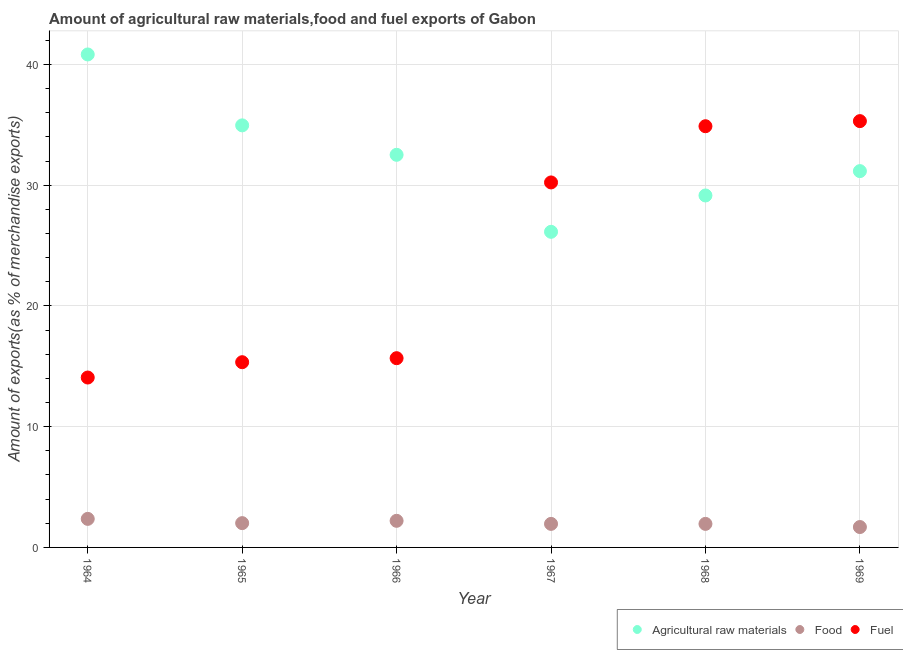How many different coloured dotlines are there?
Ensure brevity in your answer.  3. Is the number of dotlines equal to the number of legend labels?
Offer a terse response. Yes. What is the percentage of raw materials exports in 1968?
Provide a succinct answer. 29.15. Across all years, what is the maximum percentage of raw materials exports?
Offer a terse response. 40.83. Across all years, what is the minimum percentage of raw materials exports?
Provide a short and direct response. 26.14. In which year was the percentage of fuel exports maximum?
Ensure brevity in your answer.  1969. In which year was the percentage of food exports minimum?
Your answer should be very brief. 1969. What is the total percentage of raw materials exports in the graph?
Provide a succinct answer. 194.74. What is the difference between the percentage of food exports in 1968 and that in 1969?
Your response must be concise. 0.26. What is the difference between the percentage of fuel exports in 1968 and the percentage of food exports in 1967?
Provide a short and direct response. 32.93. What is the average percentage of food exports per year?
Ensure brevity in your answer.  2.03. In the year 1965, what is the difference between the percentage of fuel exports and percentage of food exports?
Keep it short and to the point. 13.33. What is the ratio of the percentage of food exports in 1964 to that in 1965?
Make the answer very short. 1.18. What is the difference between the highest and the second highest percentage of food exports?
Offer a very short reply. 0.16. What is the difference between the highest and the lowest percentage of fuel exports?
Provide a succinct answer. 21.23. In how many years, is the percentage of fuel exports greater than the average percentage of fuel exports taken over all years?
Give a very brief answer. 3. Is the sum of the percentage of raw materials exports in 1966 and 1967 greater than the maximum percentage of food exports across all years?
Your response must be concise. Yes. Is the percentage of fuel exports strictly greater than the percentage of food exports over the years?
Offer a terse response. Yes. Is the percentage of raw materials exports strictly less than the percentage of fuel exports over the years?
Your answer should be compact. No. How many dotlines are there?
Give a very brief answer. 3. What is the difference between two consecutive major ticks on the Y-axis?
Give a very brief answer. 10. Are the values on the major ticks of Y-axis written in scientific E-notation?
Provide a short and direct response. No. Does the graph contain any zero values?
Your answer should be compact. No. Does the graph contain grids?
Provide a succinct answer. Yes. How are the legend labels stacked?
Provide a short and direct response. Horizontal. What is the title of the graph?
Provide a succinct answer. Amount of agricultural raw materials,food and fuel exports of Gabon. What is the label or title of the X-axis?
Make the answer very short. Year. What is the label or title of the Y-axis?
Your response must be concise. Amount of exports(as % of merchandise exports). What is the Amount of exports(as % of merchandise exports) in Agricultural raw materials in 1964?
Your response must be concise. 40.83. What is the Amount of exports(as % of merchandise exports) in Food in 1964?
Provide a short and direct response. 2.36. What is the Amount of exports(as % of merchandise exports) of Fuel in 1964?
Offer a very short reply. 14.07. What is the Amount of exports(as % of merchandise exports) of Agricultural raw materials in 1965?
Ensure brevity in your answer.  34.95. What is the Amount of exports(as % of merchandise exports) of Food in 1965?
Keep it short and to the point. 2.01. What is the Amount of exports(as % of merchandise exports) in Fuel in 1965?
Your answer should be compact. 15.34. What is the Amount of exports(as % of merchandise exports) of Agricultural raw materials in 1966?
Give a very brief answer. 32.51. What is the Amount of exports(as % of merchandise exports) of Food in 1966?
Give a very brief answer. 2.2. What is the Amount of exports(as % of merchandise exports) of Fuel in 1966?
Ensure brevity in your answer.  15.67. What is the Amount of exports(as % of merchandise exports) in Agricultural raw materials in 1967?
Provide a short and direct response. 26.14. What is the Amount of exports(as % of merchandise exports) in Food in 1967?
Provide a short and direct response. 1.95. What is the Amount of exports(as % of merchandise exports) of Fuel in 1967?
Keep it short and to the point. 30.23. What is the Amount of exports(as % of merchandise exports) of Agricultural raw materials in 1968?
Your answer should be compact. 29.15. What is the Amount of exports(as % of merchandise exports) of Food in 1968?
Offer a terse response. 1.95. What is the Amount of exports(as % of merchandise exports) of Fuel in 1968?
Ensure brevity in your answer.  34.88. What is the Amount of exports(as % of merchandise exports) in Agricultural raw materials in 1969?
Offer a very short reply. 31.16. What is the Amount of exports(as % of merchandise exports) of Food in 1969?
Give a very brief answer. 1.69. What is the Amount of exports(as % of merchandise exports) in Fuel in 1969?
Your answer should be very brief. 35.3. Across all years, what is the maximum Amount of exports(as % of merchandise exports) in Agricultural raw materials?
Provide a succinct answer. 40.83. Across all years, what is the maximum Amount of exports(as % of merchandise exports) in Food?
Your answer should be compact. 2.36. Across all years, what is the maximum Amount of exports(as % of merchandise exports) of Fuel?
Give a very brief answer. 35.3. Across all years, what is the minimum Amount of exports(as % of merchandise exports) of Agricultural raw materials?
Keep it short and to the point. 26.14. Across all years, what is the minimum Amount of exports(as % of merchandise exports) of Food?
Ensure brevity in your answer.  1.69. Across all years, what is the minimum Amount of exports(as % of merchandise exports) of Fuel?
Your response must be concise. 14.07. What is the total Amount of exports(as % of merchandise exports) of Agricultural raw materials in the graph?
Give a very brief answer. 194.74. What is the total Amount of exports(as % of merchandise exports) in Food in the graph?
Provide a short and direct response. 12.17. What is the total Amount of exports(as % of merchandise exports) in Fuel in the graph?
Your answer should be very brief. 145.5. What is the difference between the Amount of exports(as % of merchandise exports) of Agricultural raw materials in 1964 and that in 1965?
Your answer should be compact. 5.87. What is the difference between the Amount of exports(as % of merchandise exports) of Food in 1964 and that in 1965?
Provide a succinct answer. 0.35. What is the difference between the Amount of exports(as % of merchandise exports) in Fuel in 1964 and that in 1965?
Provide a succinct answer. -1.27. What is the difference between the Amount of exports(as % of merchandise exports) of Agricultural raw materials in 1964 and that in 1966?
Ensure brevity in your answer.  8.31. What is the difference between the Amount of exports(as % of merchandise exports) of Food in 1964 and that in 1966?
Provide a short and direct response. 0.16. What is the difference between the Amount of exports(as % of merchandise exports) in Fuel in 1964 and that in 1966?
Give a very brief answer. -1.6. What is the difference between the Amount of exports(as % of merchandise exports) in Agricultural raw materials in 1964 and that in 1967?
Offer a very short reply. 14.69. What is the difference between the Amount of exports(as % of merchandise exports) of Food in 1964 and that in 1967?
Keep it short and to the point. 0.42. What is the difference between the Amount of exports(as % of merchandise exports) of Fuel in 1964 and that in 1967?
Offer a very short reply. -16.16. What is the difference between the Amount of exports(as % of merchandise exports) in Agricultural raw materials in 1964 and that in 1968?
Provide a short and direct response. 11.68. What is the difference between the Amount of exports(as % of merchandise exports) in Food in 1964 and that in 1968?
Offer a terse response. 0.41. What is the difference between the Amount of exports(as % of merchandise exports) of Fuel in 1964 and that in 1968?
Make the answer very short. -20.81. What is the difference between the Amount of exports(as % of merchandise exports) in Agricultural raw materials in 1964 and that in 1969?
Give a very brief answer. 9.66. What is the difference between the Amount of exports(as % of merchandise exports) of Food in 1964 and that in 1969?
Provide a succinct answer. 0.68. What is the difference between the Amount of exports(as % of merchandise exports) of Fuel in 1964 and that in 1969?
Make the answer very short. -21.23. What is the difference between the Amount of exports(as % of merchandise exports) of Agricultural raw materials in 1965 and that in 1966?
Make the answer very short. 2.44. What is the difference between the Amount of exports(as % of merchandise exports) in Food in 1965 and that in 1966?
Make the answer very short. -0.19. What is the difference between the Amount of exports(as % of merchandise exports) in Fuel in 1965 and that in 1966?
Offer a terse response. -0.33. What is the difference between the Amount of exports(as % of merchandise exports) of Agricultural raw materials in 1965 and that in 1967?
Ensure brevity in your answer.  8.82. What is the difference between the Amount of exports(as % of merchandise exports) in Food in 1965 and that in 1967?
Your answer should be compact. 0.06. What is the difference between the Amount of exports(as % of merchandise exports) in Fuel in 1965 and that in 1967?
Keep it short and to the point. -14.89. What is the difference between the Amount of exports(as % of merchandise exports) of Agricultural raw materials in 1965 and that in 1968?
Provide a short and direct response. 5.81. What is the difference between the Amount of exports(as % of merchandise exports) of Food in 1965 and that in 1968?
Your answer should be compact. 0.06. What is the difference between the Amount of exports(as % of merchandise exports) of Fuel in 1965 and that in 1968?
Your response must be concise. -19.54. What is the difference between the Amount of exports(as % of merchandise exports) in Agricultural raw materials in 1965 and that in 1969?
Your answer should be very brief. 3.79. What is the difference between the Amount of exports(as % of merchandise exports) in Food in 1965 and that in 1969?
Your response must be concise. 0.32. What is the difference between the Amount of exports(as % of merchandise exports) in Fuel in 1965 and that in 1969?
Give a very brief answer. -19.97. What is the difference between the Amount of exports(as % of merchandise exports) in Agricultural raw materials in 1966 and that in 1967?
Your response must be concise. 6.38. What is the difference between the Amount of exports(as % of merchandise exports) in Food in 1966 and that in 1967?
Your response must be concise. 0.25. What is the difference between the Amount of exports(as % of merchandise exports) in Fuel in 1966 and that in 1967?
Your response must be concise. -14.55. What is the difference between the Amount of exports(as % of merchandise exports) in Agricultural raw materials in 1966 and that in 1968?
Give a very brief answer. 3.37. What is the difference between the Amount of exports(as % of merchandise exports) of Food in 1966 and that in 1968?
Your answer should be very brief. 0.25. What is the difference between the Amount of exports(as % of merchandise exports) of Fuel in 1966 and that in 1968?
Ensure brevity in your answer.  -19.21. What is the difference between the Amount of exports(as % of merchandise exports) of Agricultural raw materials in 1966 and that in 1969?
Your answer should be very brief. 1.35. What is the difference between the Amount of exports(as % of merchandise exports) in Food in 1966 and that in 1969?
Keep it short and to the point. 0.51. What is the difference between the Amount of exports(as % of merchandise exports) of Fuel in 1966 and that in 1969?
Offer a terse response. -19.63. What is the difference between the Amount of exports(as % of merchandise exports) in Agricultural raw materials in 1967 and that in 1968?
Ensure brevity in your answer.  -3.01. What is the difference between the Amount of exports(as % of merchandise exports) in Food in 1967 and that in 1968?
Your response must be concise. -0. What is the difference between the Amount of exports(as % of merchandise exports) in Fuel in 1967 and that in 1968?
Your answer should be compact. -4.66. What is the difference between the Amount of exports(as % of merchandise exports) of Agricultural raw materials in 1967 and that in 1969?
Offer a terse response. -5.03. What is the difference between the Amount of exports(as % of merchandise exports) of Food in 1967 and that in 1969?
Your answer should be very brief. 0.26. What is the difference between the Amount of exports(as % of merchandise exports) of Fuel in 1967 and that in 1969?
Your answer should be very brief. -5.08. What is the difference between the Amount of exports(as % of merchandise exports) of Agricultural raw materials in 1968 and that in 1969?
Offer a very short reply. -2.02. What is the difference between the Amount of exports(as % of merchandise exports) of Food in 1968 and that in 1969?
Your response must be concise. 0.26. What is the difference between the Amount of exports(as % of merchandise exports) of Fuel in 1968 and that in 1969?
Your answer should be compact. -0.42. What is the difference between the Amount of exports(as % of merchandise exports) of Agricultural raw materials in 1964 and the Amount of exports(as % of merchandise exports) of Food in 1965?
Keep it short and to the point. 38.81. What is the difference between the Amount of exports(as % of merchandise exports) in Agricultural raw materials in 1964 and the Amount of exports(as % of merchandise exports) in Fuel in 1965?
Make the answer very short. 25.49. What is the difference between the Amount of exports(as % of merchandise exports) of Food in 1964 and the Amount of exports(as % of merchandise exports) of Fuel in 1965?
Offer a terse response. -12.97. What is the difference between the Amount of exports(as % of merchandise exports) in Agricultural raw materials in 1964 and the Amount of exports(as % of merchandise exports) in Food in 1966?
Your response must be concise. 38.62. What is the difference between the Amount of exports(as % of merchandise exports) of Agricultural raw materials in 1964 and the Amount of exports(as % of merchandise exports) of Fuel in 1966?
Keep it short and to the point. 25.15. What is the difference between the Amount of exports(as % of merchandise exports) in Food in 1964 and the Amount of exports(as % of merchandise exports) in Fuel in 1966?
Your answer should be very brief. -13.31. What is the difference between the Amount of exports(as % of merchandise exports) in Agricultural raw materials in 1964 and the Amount of exports(as % of merchandise exports) in Food in 1967?
Your answer should be compact. 38.88. What is the difference between the Amount of exports(as % of merchandise exports) of Agricultural raw materials in 1964 and the Amount of exports(as % of merchandise exports) of Fuel in 1967?
Your response must be concise. 10.6. What is the difference between the Amount of exports(as % of merchandise exports) of Food in 1964 and the Amount of exports(as % of merchandise exports) of Fuel in 1967?
Give a very brief answer. -27.86. What is the difference between the Amount of exports(as % of merchandise exports) of Agricultural raw materials in 1964 and the Amount of exports(as % of merchandise exports) of Food in 1968?
Offer a very short reply. 38.88. What is the difference between the Amount of exports(as % of merchandise exports) of Agricultural raw materials in 1964 and the Amount of exports(as % of merchandise exports) of Fuel in 1968?
Provide a short and direct response. 5.94. What is the difference between the Amount of exports(as % of merchandise exports) of Food in 1964 and the Amount of exports(as % of merchandise exports) of Fuel in 1968?
Your answer should be very brief. -32.52. What is the difference between the Amount of exports(as % of merchandise exports) of Agricultural raw materials in 1964 and the Amount of exports(as % of merchandise exports) of Food in 1969?
Provide a succinct answer. 39.14. What is the difference between the Amount of exports(as % of merchandise exports) in Agricultural raw materials in 1964 and the Amount of exports(as % of merchandise exports) in Fuel in 1969?
Offer a terse response. 5.52. What is the difference between the Amount of exports(as % of merchandise exports) in Food in 1964 and the Amount of exports(as % of merchandise exports) in Fuel in 1969?
Provide a short and direct response. -32.94. What is the difference between the Amount of exports(as % of merchandise exports) of Agricultural raw materials in 1965 and the Amount of exports(as % of merchandise exports) of Food in 1966?
Make the answer very short. 32.75. What is the difference between the Amount of exports(as % of merchandise exports) in Agricultural raw materials in 1965 and the Amount of exports(as % of merchandise exports) in Fuel in 1966?
Your answer should be very brief. 19.28. What is the difference between the Amount of exports(as % of merchandise exports) of Food in 1965 and the Amount of exports(as % of merchandise exports) of Fuel in 1966?
Give a very brief answer. -13.66. What is the difference between the Amount of exports(as % of merchandise exports) in Agricultural raw materials in 1965 and the Amount of exports(as % of merchandise exports) in Food in 1967?
Offer a very short reply. 33. What is the difference between the Amount of exports(as % of merchandise exports) in Agricultural raw materials in 1965 and the Amount of exports(as % of merchandise exports) in Fuel in 1967?
Offer a terse response. 4.73. What is the difference between the Amount of exports(as % of merchandise exports) of Food in 1965 and the Amount of exports(as % of merchandise exports) of Fuel in 1967?
Offer a very short reply. -28.21. What is the difference between the Amount of exports(as % of merchandise exports) in Agricultural raw materials in 1965 and the Amount of exports(as % of merchandise exports) in Food in 1968?
Make the answer very short. 33. What is the difference between the Amount of exports(as % of merchandise exports) of Agricultural raw materials in 1965 and the Amount of exports(as % of merchandise exports) of Fuel in 1968?
Give a very brief answer. 0.07. What is the difference between the Amount of exports(as % of merchandise exports) in Food in 1965 and the Amount of exports(as % of merchandise exports) in Fuel in 1968?
Your response must be concise. -32.87. What is the difference between the Amount of exports(as % of merchandise exports) in Agricultural raw materials in 1965 and the Amount of exports(as % of merchandise exports) in Food in 1969?
Offer a very short reply. 33.26. What is the difference between the Amount of exports(as % of merchandise exports) of Agricultural raw materials in 1965 and the Amount of exports(as % of merchandise exports) of Fuel in 1969?
Ensure brevity in your answer.  -0.35. What is the difference between the Amount of exports(as % of merchandise exports) in Food in 1965 and the Amount of exports(as % of merchandise exports) in Fuel in 1969?
Make the answer very short. -33.29. What is the difference between the Amount of exports(as % of merchandise exports) of Agricultural raw materials in 1966 and the Amount of exports(as % of merchandise exports) of Food in 1967?
Your answer should be compact. 30.57. What is the difference between the Amount of exports(as % of merchandise exports) of Agricultural raw materials in 1966 and the Amount of exports(as % of merchandise exports) of Fuel in 1967?
Ensure brevity in your answer.  2.29. What is the difference between the Amount of exports(as % of merchandise exports) of Food in 1966 and the Amount of exports(as % of merchandise exports) of Fuel in 1967?
Provide a short and direct response. -28.02. What is the difference between the Amount of exports(as % of merchandise exports) in Agricultural raw materials in 1966 and the Amount of exports(as % of merchandise exports) in Food in 1968?
Your answer should be very brief. 30.57. What is the difference between the Amount of exports(as % of merchandise exports) of Agricultural raw materials in 1966 and the Amount of exports(as % of merchandise exports) of Fuel in 1968?
Your response must be concise. -2.37. What is the difference between the Amount of exports(as % of merchandise exports) in Food in 1966 and the Amount of exports(as % of merchandise exports) in Fuel in 1968?
Your answer should be compact. -32.68. What is the difference between the Amount of exports(as % of merchandise exports) of Agricultural raw materials in 1966 and the Amount of exports(as % of merchandise exports) of Food in 1969?
Give a very brief answer. 30.83. What is the difference between the Amount of exports(as % of merchandise exports) in Agricultural raw materials in 1966 and the Amount of exports(as % of merchandise exports) in Fuel in 1969?
Keep it short and to the point. -2.79. What is the difference between the Amount of exports(as % of merchandise exports) in Food in 1966 and the Amount of exports(as % of merchandise exports) in Fuel in 1969?
Ensure brevity in your answer.  -33.1. What is the difference between the Amount of exports(as % of merchandise exports) of Agricultural raw materials in 1967 and the Amount of exports(as % of merchandise exports) of Food in 1968?
Your answer should be compact. 24.19. What is the difference between the Amount of exports(as % of merchandise exports) of Agricultural raw materials in 1967 and the Amount of exports(as % of merchandise exports) of Fuel in 1968?
Provide a succinct answer. -8.74. What is the difference between the Amount of exports(as % of merchandise exports) in Food in 1967 and the Amount of exports(as % of merchandise exports) in Fuel in 1968?
Your response must be concise. -32.93. What is the difference between the Amount of exports(as % of merchandise exports) in Agricultural raw materials in 1967 and the Amount of exports(as % of merchandise exports) in Food in 1969?
Ensure brevity in your answer.  24.45. What is the difference between the Amount of exports(as % of merchandise exports) in Agricultural raw materials in 1967 and the Amount of exports(as % of merchandise exports) in Fuel in 1969?
Your answer should be very brief. -9.17. What is the difference between the Amount of exports(as % of merchandise exports) of Food in 1967 and the Amount of exports(as % of merchandise exports) of Fuel in 1969?
Your response must be concise. -33.35. What is the difference between the Amount of exports(as % of merchandise exports) in Agricultural raw materials in 1968 and the Amount of exports(as % of merchandise exports) in Food in 1969?
Provide a succinct answer. 27.46. What is the difference between the Amount of exports(as % of merchandise exports) in Agricultural raw materials in 1968 and the Amount of exports(as % of merchandise exports) in Fuel in 1969?
Your answer should be compact. -6.16. What is the difference between the Amount of exports(as % of merchandise exports) of Food in 1968 and the Amount of exports(as % of merchandise exports) of Fuel in 1969?
Provide a succinct answer. -33.35. What is the average Amount of exports(as % of merchandise exports) of Agricultural raw materials per year?
Offer a very short reply. 32.46. What is the average Amount of exports(as % of merchandise exports) in Food per year?
Your answer should be compact. 2.03. What is the average Amount of exports(as % of merchandise exports) in Fuel per year?
Your answer should be very brief. 24.25. In the year 1964, what is the difference between the Amount of exports(as % of merchandise exports) of Agricultural raw materials and Amount of exports(as % of merchandise exports) of Food?
Provide a succinct answer. 38.46. In the year 1964, what is the difference between the Amount of exports(as % of merchandise exports) in Agricultural raw materials and Amount of exports(as % of merchandise exports) in Fuel?
Your answer should be compact. 26.76. In the year 1964, what is the difference between the Amount of exports(as % of merchandise exports) of Food and Amount of exports(as % of merchandise exports) of Fuel?
Your answer should be compact. -11.71. In the year 1965, what is the difference between the Amount of exports(as % of merchandise exports) in Agricultural raw materials and Amount of exports(as % of merchandise exports) in Food?
Your answer should be compact. 32.94. In the year 1965, what is the difference between the Amount of exports(as % of merchandise exports) in Agricultural raw materials and Amount of exports(as % of merchandise exports) in Fuel?
Your response must be concise. 19.61. In the year 1965, what is the difference between the Amount of exports(as % of merchandise exports) in Food and Amount of exports(as % of merchandise exports) in Fuel?
Ensure brevity in your answer.  -13.33. In the year 1966, what is the difference between the Amount of exports(as % of merchandise exports) in Agricultural raw materials and Amount of exports(as % of merchandise exports) in Food?
Ensure brevity in your answer.  30.31. In the year 1966, what is the difference between the Amount of exports(as % of merchandise exports) in Agricultural raw materials and Amount of exports(as % of merchandise exports) in Fuel?
Offer a very short reply. 16.84. In the year 1966, what is the difference between the Amount of exports(as % of merchandise exports) in Food and Amount of exports(as % of merchandise exports) in Fuel?
Offer a very short reply. -13.47. In the year 1967, what is the difference between the Amount of exports(as % of merchandise exports) of Agricultural raw materials and Amount of exports(as % of merchandise exports) of Food?
Keep it short and to the point. 24.19. In the year 1967, what is the difference between the Amount of exports(as % of merchandise exports) of Agricultural raw materials and Amount of exports(as % of merchandise exports) of Fuel?
Your response must be concise. -4.09. In the year 1967, what is the difference between the Amount of exports(as % of merchandise exports) of Food and Amount of exports(as % of merchandise exports) of Fuel?
Your response must be concise. -28.28. In the year 1968, what is the difference between the Amount of exports(as % of merchandise exports) of Agricultural raw materials and Amount of exports(as % of merchandise exports) of Food?
Your answer should be very brief. 27.2. In the year 1968, what is the difference between the Amount of exports(as % of merchandise exports) of Agricultural raw materials and Amount of exports(as % of merchandise exports) of Fuel?
Give a very brief answer. -5.73. In the year 1968, what is the difference between the Amount of exports(as % of merchandise exports) of Food and Amount of exports(as % of merchandise exports) of Fuel?
Give a very brief answer. -32.93. In the year 1969, what is the difference between the Amount of exports(as % of merchandise exports) in Agricultural raw materials and Amount of exports(as % of merchandise exports) in Food?
Offer a very short reply. 29.48. In the year 1969, what is the difference between the Amount of exports(as % of merchandise exports) of Agricultural raw materials and Amount of exports(as % of merchandise exports) of Fuel?
Give a very brief answer. -4.14. In the year 1969, what is the difference between the Amount of exports(as % of merchandise exports) of Food and Amount of exports(as % of merchandise exports) of Fuel?
Your answer should be compact. -33.62. What is the ratio of the Amount of exports(as % of merchandise exports) of Agricultural raw materials in 1964 to that in 1965?
Your answer should be compact. 1.17. What is the ratio of the Amount of exports(as % of merchandise exports) of Food in 1964 to that in 1965?
Offer a terse response. 1.18. What is the ratio of the Amount of exports(as % of merchandise exports) in Fuel in 1964 to that in 1965?
Give a very brief answer. 0.92. What is the ratio of the Amount of exports(as % of merchandise exports) of Agricultural raw materials in 1964 to that in 1966?
Give a very brief answer. 1.26. What is the ratio of the Amount of exports(as % of merchandise exports) of Food in 1964 to that in 1966?
Your answer should be very brief. 1.07. What is the ratio of the Amount of exports(as % of merchandise exports) of Fuel in 1964 to that in 1966?
Provide a short and direct response. 0.9. What is the ratio of the Amount of exports(as % of merchandise exports) of Agricultural raw materials in 1964 to that in 1967?
Provide a short and direct response. 1.56. What is the ratio of the Amount of exports(as % of merchandise exports) in Food in 1964 to that in 1967?
Your answer should be compact. 1.21. What is the ratio of the Amount of exports(as % of merchandise exports) in Fuel in 1964 to that in 1967?
Keep it short and to the point. 0.47. What is the ratio of the Amount of exports(as % of merchandise exports) in Agricultural raw materials in 1964 to that in 1968?
Make the answer very short. 1.4. What is the ratio of the Amount of exports(as % of merchandise exports) in Food in 1964 to that in 1968?
Your answer should be very brief. 1.21. What is the ratio of the Amount of exports(as % of merchandise exports) of Fuel in 1964 to that in 1968?
Your answer should be compact. 0.4. What is the ratio of the Amount of exports(as % of merchandise exports) of Agricultural raw materials in 1964 to that in 1969?
Keep it short and to the point. 1.31. What is the ratio of the Amount of exports(as % of merchandise exports) of Food in 1964 to that in 1969?
Keep it short and to the point. 1.4. What is the ratio of the Amount of exports(as % of merchandise exports) of Fuel in 1964 to that in 1969?
Provide a short and direct response. 0.4. What is the ratio of the Amount of exports(as % of merchandise exports) in Agricultural raw materials in 1965 to that in 1966?
Make the answer very short. 1.07. What is the ratio of the Amount of exports(as % of merchandise exports) in Food in 1965 to that in 1966?
Offer a very short reply. 0.91. What is the ratio of the Amount of exports(as % of merchandise exports) of Fuel in 1965 to that in 1966?
Give a very brief answer. 0.98. What is the ratio of the Amount of exports(as % of merchandise exports) in Agricultural raw materials in 1965 to that in 1967?
Provide a short and direct response. 1.34. What is the ratio of the Amount of exports(as % of merchandise exports) in Food in 1965 to that in 1967?
Your answer should be compact. 1.03. What is the ratio of the Amount of exports(as % of merchandise exports) in Fuel in 1965 to that in 1967?
Offer a very short reply. 0.51. What is the ratio of the Amount of exports(as % of merchandise exports) in Agricultural raw materials in 1965 to that in 1968?
Your answer should be very brief. 1.2. What is the ratio of the Amount of exports(as % of merchandise exports) of Food in 1965 to that in 1968?
Ensure brevity in your answer.  1.03. What is the ratio of the Amount of exports(as % of merchandise exports) in Fuel in 1965 to that in 1968?
Provide a short and direct response. 0.44. What is the ratio of the Amount of exports(as % of merchandise exports) of Agricultural raw materials in 1965 to that in 1969?
Make the answer very short. 1.12. What is the ratio of the Amount of exports(as % of merchandise exports) of Food in 1965 to that in 1969?
Offer a terse response. 1.19. What is the ratio of the Amount of exports(as % of merchandise exports) in Fuel in 1965 to that in 1969?
Keep it short and to the point. 0.43. What is the ratio of the Amount of exports(as % of merchandise exports) of Agricultural raw materials in 1966 to that in 1967?
Keep it short and to the point. 1.24. What is the ratio of the Amount of exports(as % of merchandise exports) of Food in 1966 to that in 1967?
Provide a succinct answer. 1.13. What is the ratio of the Amount of exports(as % of merchandise exports) of Fuel in 1966 to that in 1967?
Provide a short and direct response. 0.52. What is the ratio of the Amount of exports(as % of merchandise exports) of Agricultural raw materials in 1966 to that in 1968?
Give a very brief answer. 1.12. What is the ratio of the Amount of exports(as % of merchandise exports) of Food in 1966 to that in 1968?
Ensure brevity in your answer.  1.13. What is the ratio of the Amount of exports(as % of merchandise exports) in Fuel in 1966 to that in 1968?
Your response must be concise. 0.45. What is the ratio of the Amount of exports(as % of merchandise exports) in Agricultural raw materials in 1966 to that in 1969?
Make the answer very short. 1.04. What is the ratio of the Amount of exports(as % of merchandise exports) in Food in 1966 to that in 1969?
Give a very brief answer. 1.3. What is the ratio of the Amount of exports(as % of merchandise exports) in Fuel in 1966 to that in 1969?
Your answer should be compact. 0.44. What is the ratio of the Amount of exports(as % of merchandise exports) of Agricultural raw materials in 1967 to that in 1968?
Your answer should be compact. 0.9. What is the ratio of the Amount of exports(as % of merchandise exports) of Fuel in 1967 to that in 1968?
Offer a very short reply. 0.87. What is the ratio of the Amount of exports(as % of merchandise exports) in Agricultural raw materials in 1967 to that in 1969?
Give a very brief answer. 0.84. What is the ratio of the Amount of exports(as % of merchandise exports) in Food in 1967 to that in 1969?
Give a very brief answer. 1.15. What is the ratio of the Amount of exports(as % of merchandise exports) of Fuel in 1967 to that in 1969?
Your response must be concise. 0.86. What is the ratio of the Amount of exports(as % of merchandise exports) of Agricultural raw materials in 1968 to that in 1969?
Offer a terse response. 0.94. What is the ratio of the Amount of exports(as % of merchandise exports) of Food in 1968 to that in 1969?
Offer a very short reply. 1.15. What is the difference between the highest and the second highest Amount of exports(as % of merchandise exports) in Agricultural raw materials?
Ensure brevity in your answer.  5.87. What is the difference between the highest and the second highest Amount of exports(as % of merchandise exports) in Food?
Keep it short and to the point. 0.16. What is the difference between the highest and the second highest Amount of exports(as % of merchandise exports) in Fuel?
Offer a terse response. 0.42. What is the difference between the highest and the lowest Amount of exports(as % of merchandise exports) in Agricultural raw materials?
Your answer should be very brief. 14.69. What is the difference between the highest and the lowest Amount of exports(as % of merchandise exports) of Food?
Provide a succinct answer. 0.68. What is the difference between the highest and the lowest Amount of exports(as % of merchandise exports) in Fuel?
Keep it short and to the point. 21.23. 